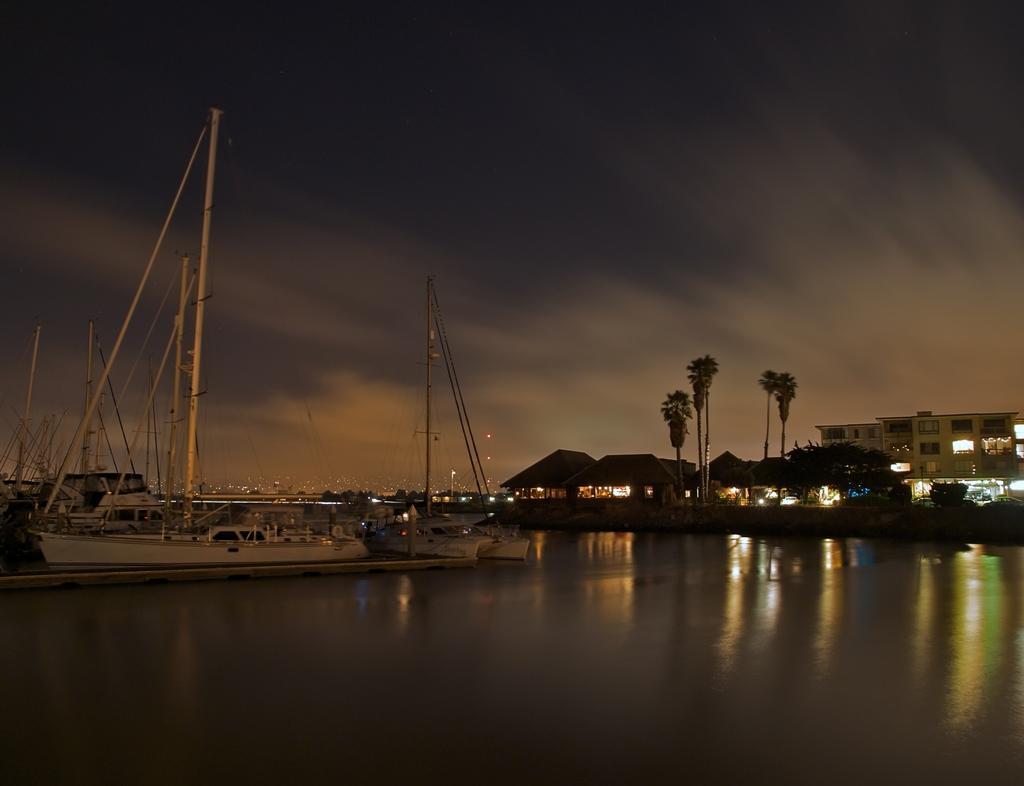Could you give a brief overview of what you see in this image? In this image, on the left side, we can see some ships. On the right side, we can see some trees, building, lights, hut. At the top, we can see a sky, at the bottom, we can see a water in a lake. 